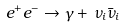<formula> <loc_0><loc_0><loc_500><loc_500>e ^ { + } e ^ { - } \to \gamma + \, \nu _ { i } \bar { \nu } _ { i }</formula> 